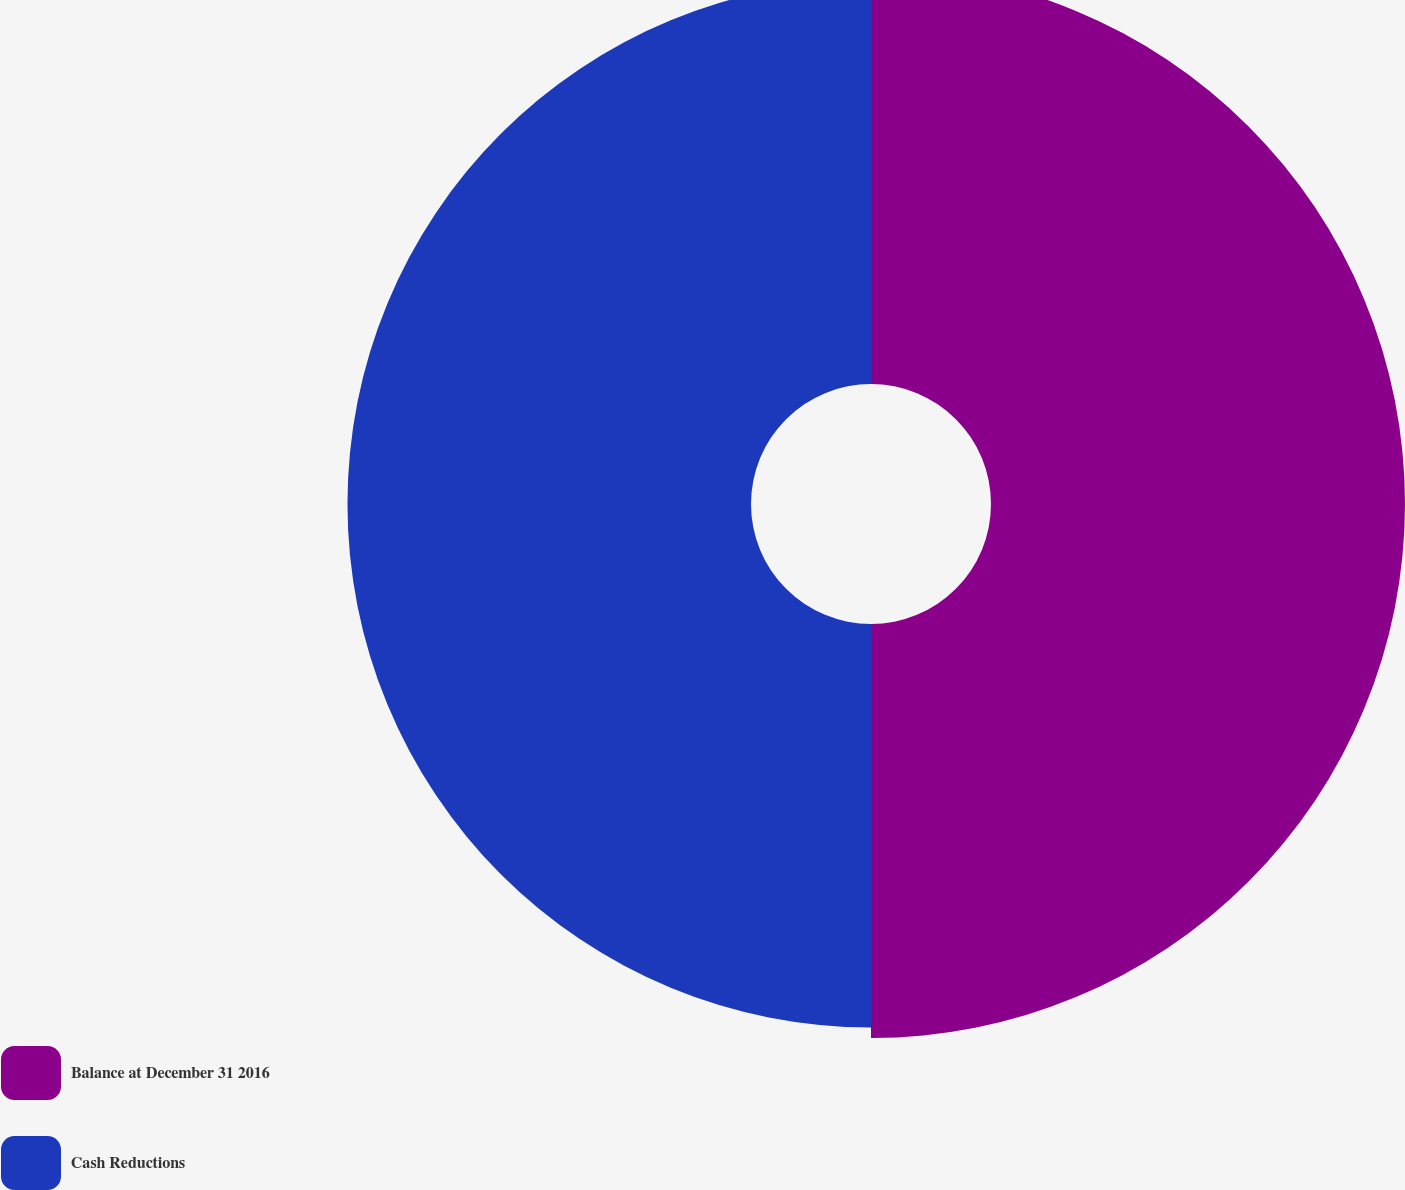Convert chart. <chart><loc_0><loc_0><loc_500><loc_500><pie_chart><fcel>Balance at December 31 2016<fcel>Cash Reductions<nl><fcel>50.64%<fcel>49.36%<nl></chart> 